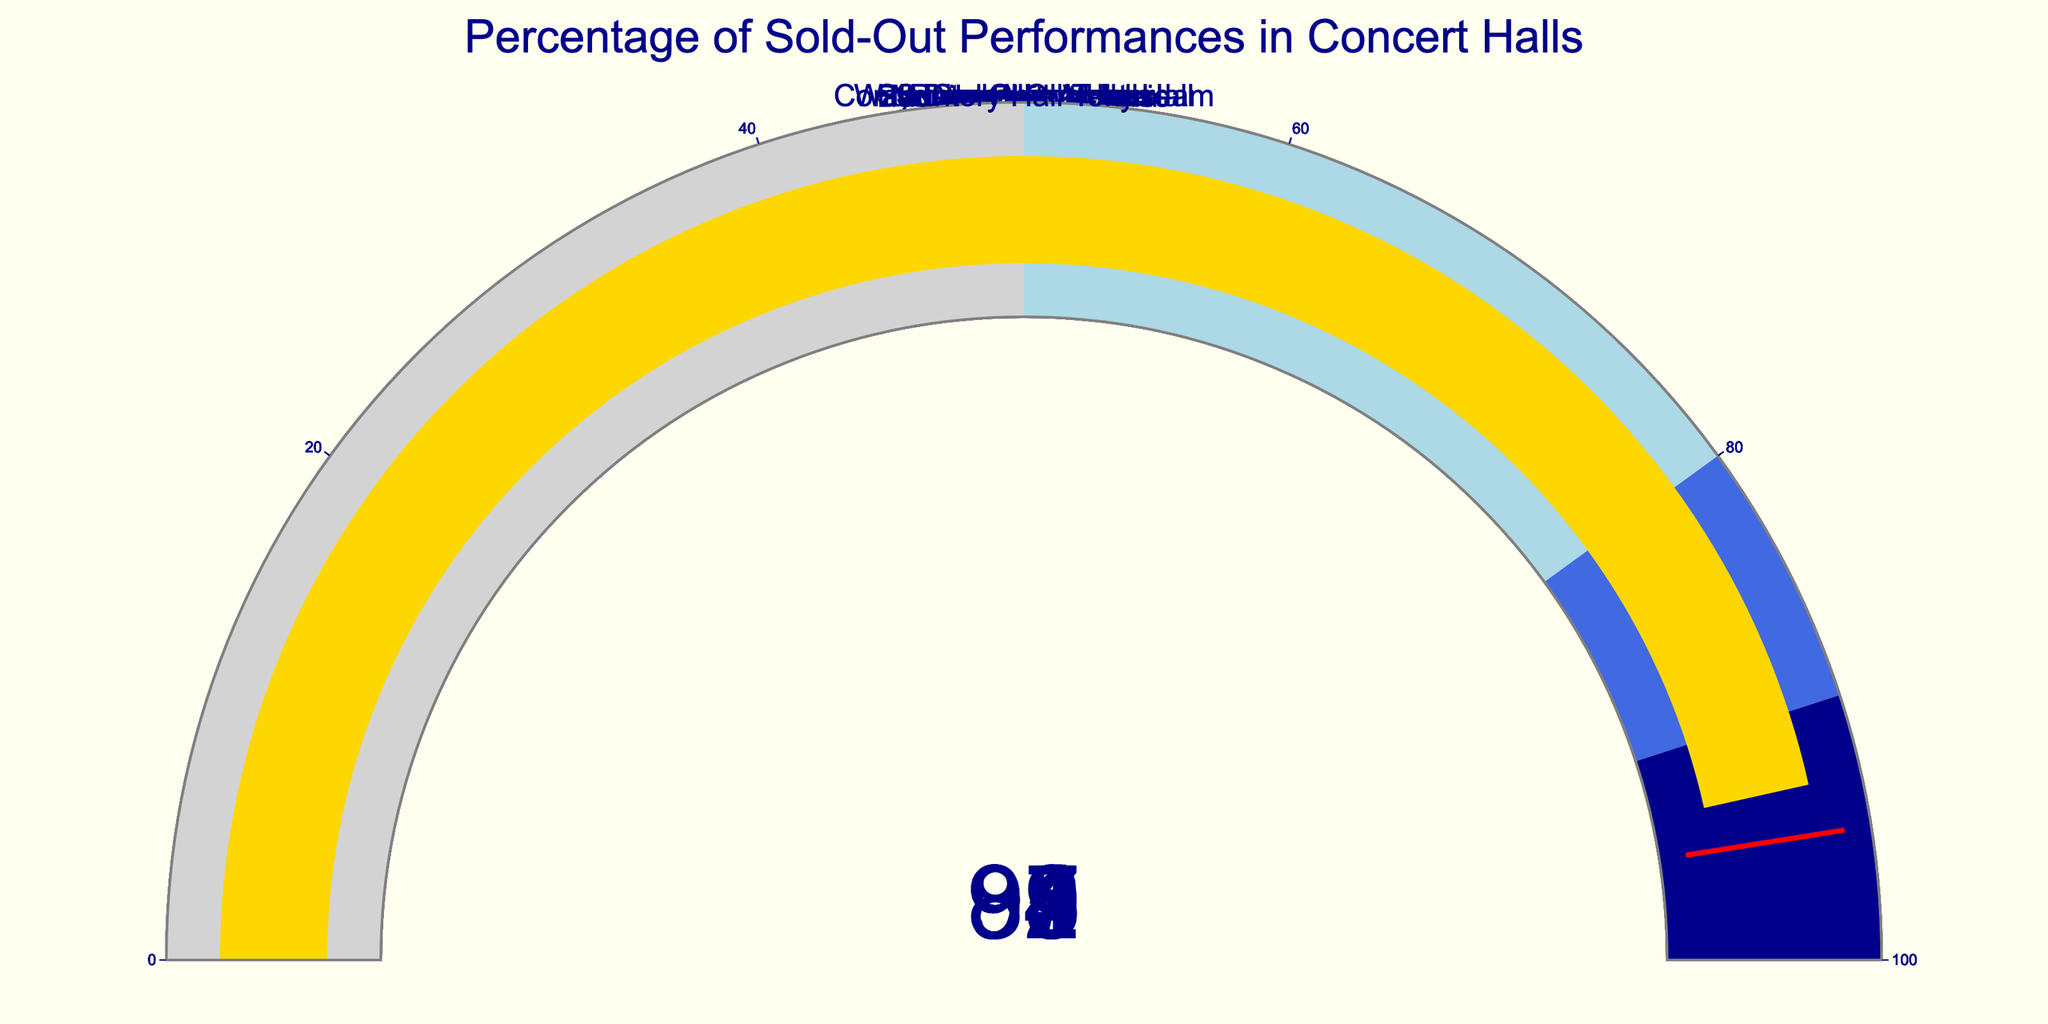What is the percentage of sold-out performances at Carnegie Hall? The gauge chart for Carnegie Hall displays a single number indicating the percentage of sold-out performances.
Answer: 98 What color represents the highest range of percentages on the gauges? Observing the color scheme on the gauge charts, the highest range (90-100%) is indicated by a specific color.
Answer: dark blue Which concert hall has the lowest percentage of sold-out performances? By comparing the displayed percentages across all gauges, the venue with the smallest value can be identified.
Answer: Berliner Philharmonie What's the average percentage of sold-out performances among Carnegie Hall, Royal Albert Hall, and Sydney Opera House? First, find the percentages (98, 95, 92), then calculate their average: (98 + 95 + 92) / 3 = 95.
Answer: 95 Is the percentage of sold-out performances at Musikverein Vienna greater than at Concertgebouw Amsterdam? Compare the displayed percentages on the gauges: Musikverein Vienna is 97 and Concertgebouw Amsterdam is 94.
Answer: Yes What is the median percentage of all the concert halls listed? Arrange the percentages in ascending order (89, 91, 92, 93, 94, 95, 97, 98) and find the middle value(s). The median is the average of the 4th and 5th values: (93 + 94) / 2 = 93.5.
Answer: 93.5 How many concert halls have a percentage of sold-out performances below the threshold of 95%? Identify the gauges with values less than 95 (Sydney Opera House, Berliner Philharmonie, Concertgebouw Amsterdam, Walt Disney Concert Hall, Suntory Hall Tokyo) and count them.
Answer: 5 Which venue has a percentage closest to 90%? Compare the percentages displayed on all the gauges: Sydney Opera House is 92, Berliner Philharmonie is 89, and Walt Disney Concert Hall is 91. Berliner Philharmonie is closest to 90.
Answer: Berliner Philharmonie What is the difference in sold-out performance percentages between Walt Disney Concert Hall and Suntory Hall Tokyo? Identify the percentages for both venues: Walt Disney Concert Hall is 91, Suntory Hall Tokyo is 93. Calculate the difference: 93 - 91 = 2.
Answer: 2 